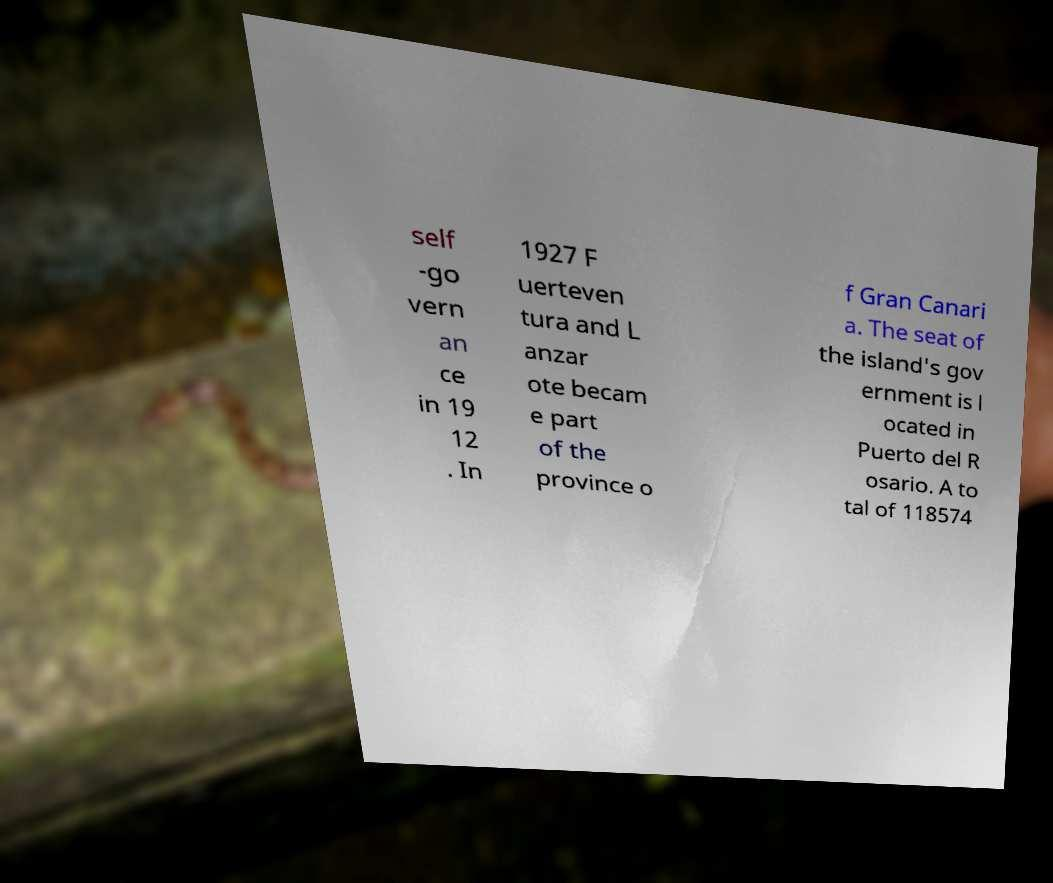Please read and relay the text visible in this image. What does it say? self -go vern an ce in 19 12 . In 1927 F uerteven tura and L anzar ote becam e part of the province o f Gran Canari a. The seat of the island's gov ernment is l ocated in Puerto del R osario. A to tal of 118574 